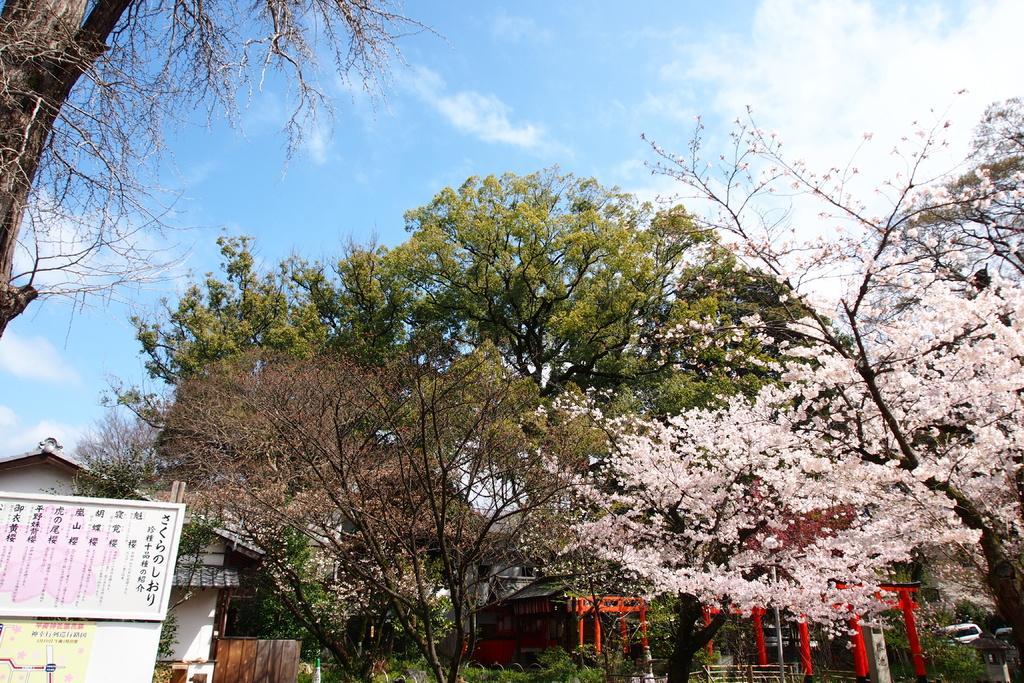How would you summarize this image in a sentence or two? In this image I see number of buildings and I see the board over here on which there is something written and I see number of trees. In the background I see the clear sky. 